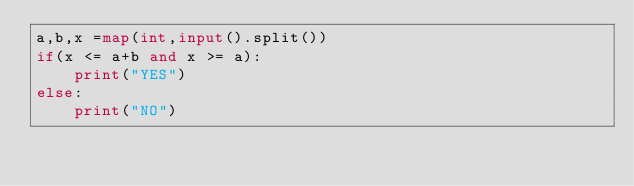<code> <loc_0><loc_0><loc_500><loc_500><_Python_>a,b,x =map(int,input().split())
if(x <= a+b and x >= a):
    print("YES")
else:
    print("NO")</code> 